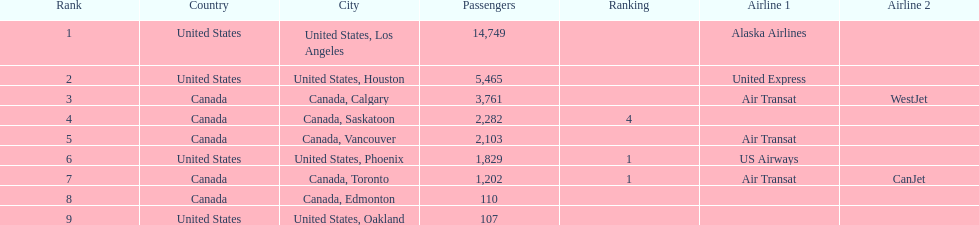How many cities from canada are on this list? 5. 